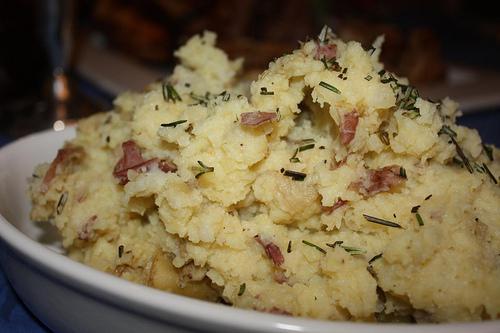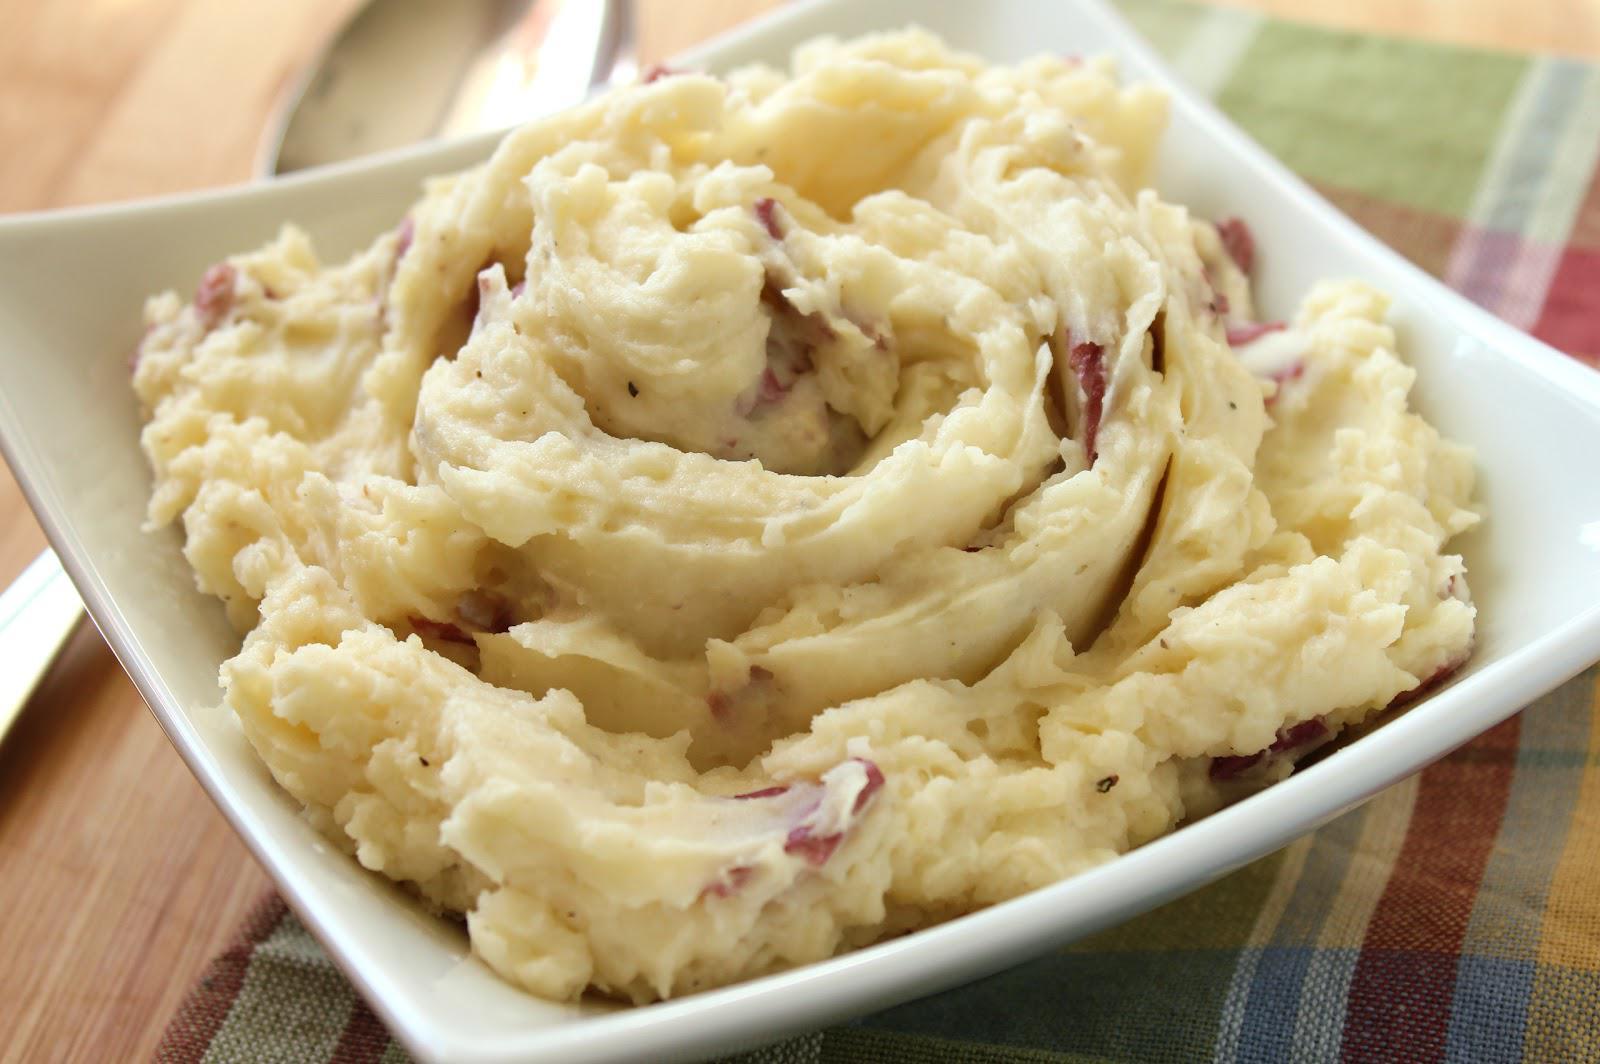The first image is the image on the left, the second image is the image on the right. Assess this claim about the two images: "An item of silverware is on a napkin that also holds a round white dish containing mashed potatoes.". Correct or not? Answer yes or no. No. 